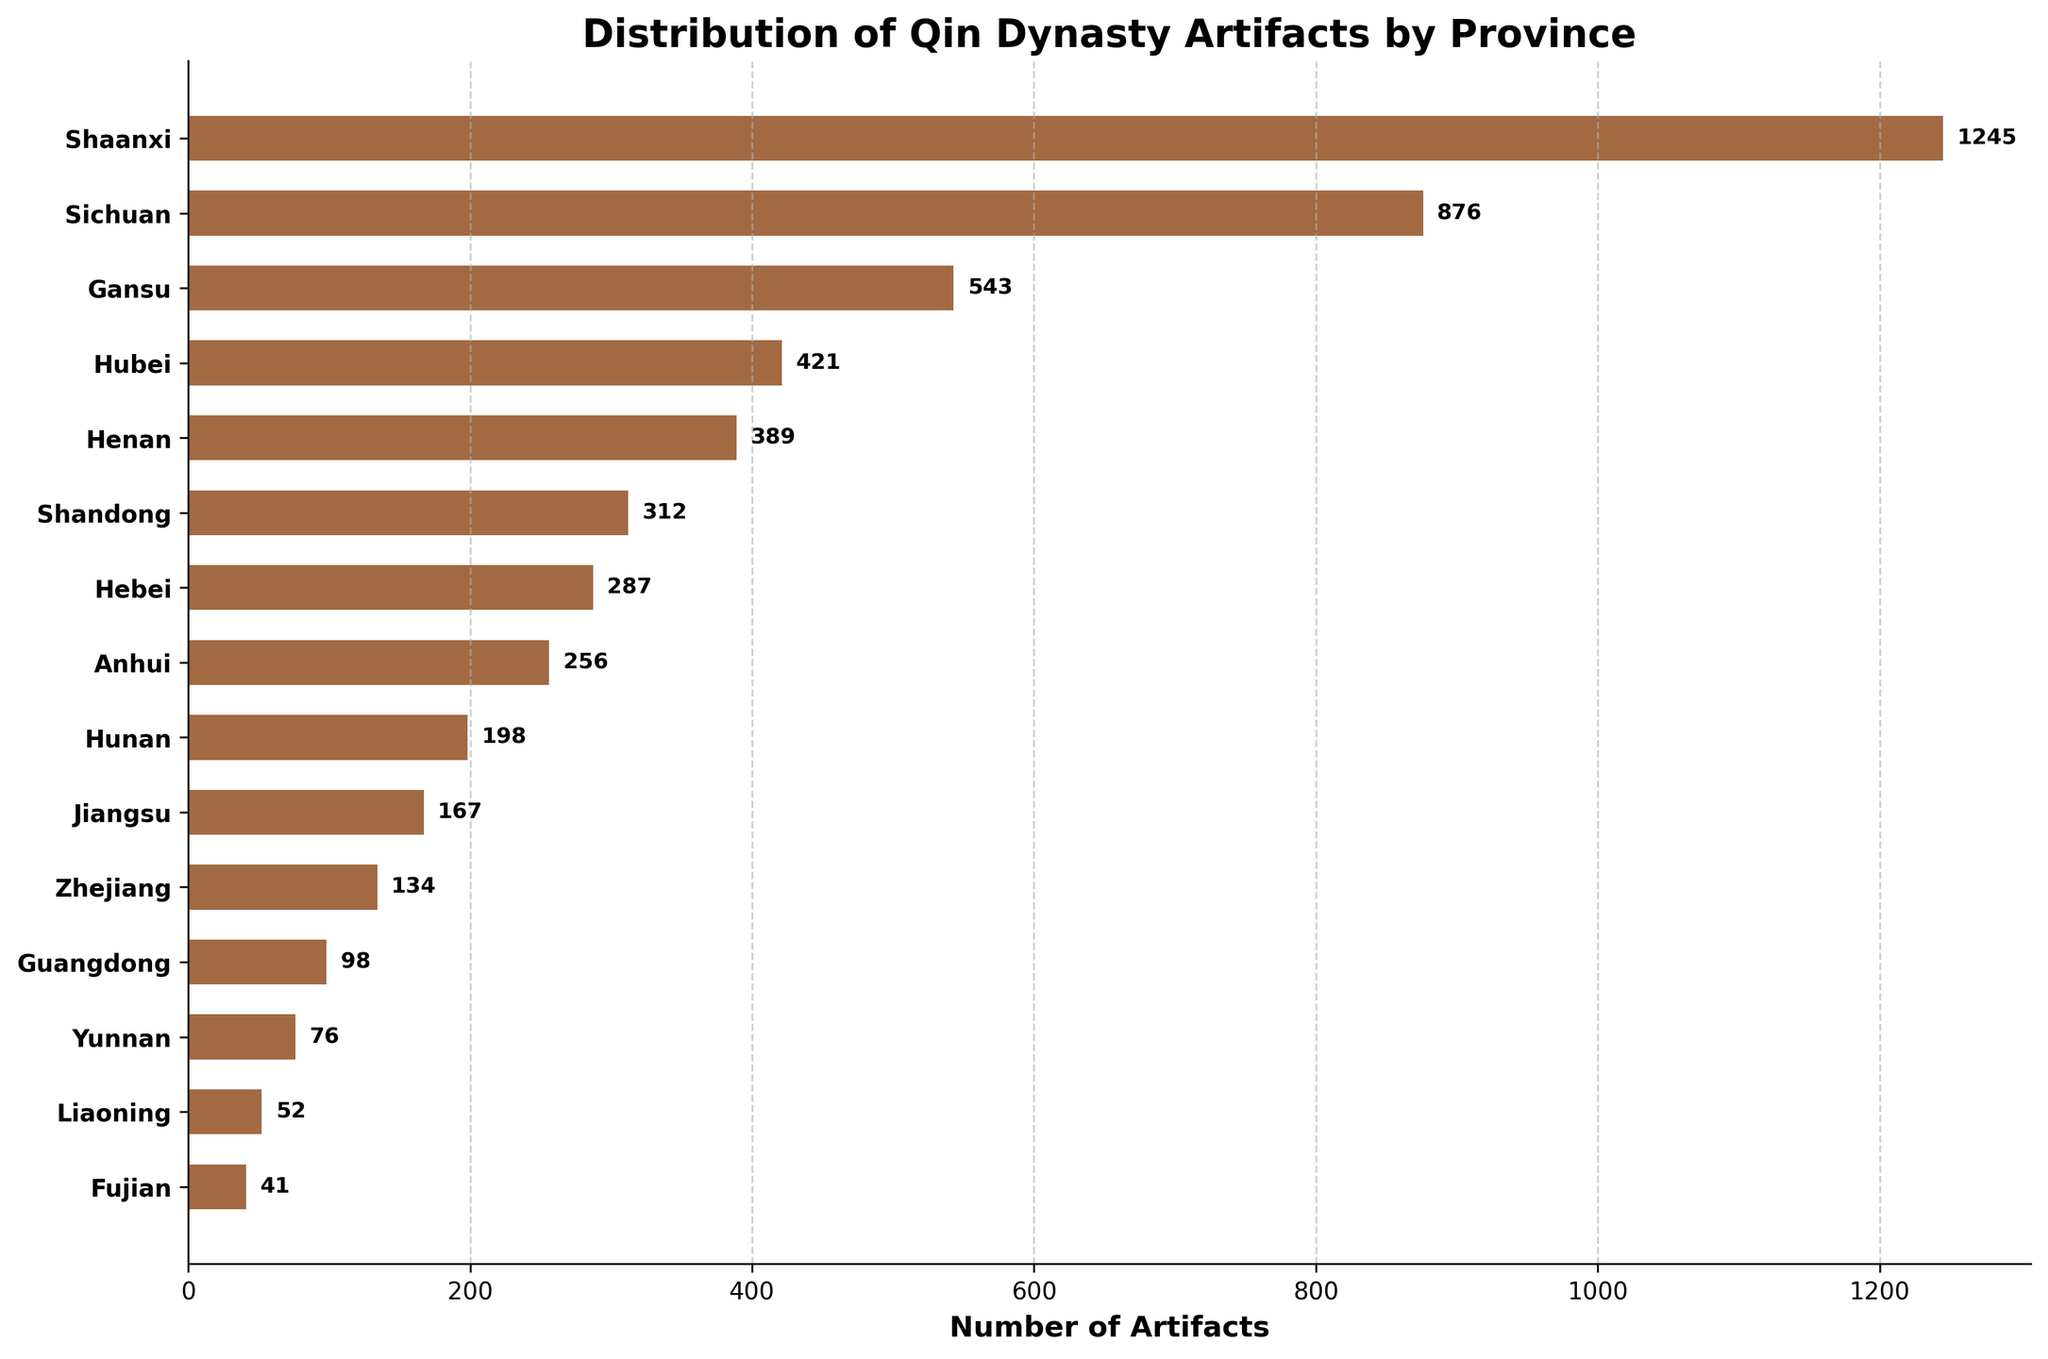Which province has the highest number of Qin Dynasty artifacts? The bar with the longest length corresponds to Shaanxi, indicating it has the highest number of artifacts.
Answer: Shaanxi What is the total number of artifacts found in Sichuan and Gansu combined? Summing the number of artifacts in Sichuan (876) and Gansu (543) results in: 876 + 543.
Answer: 1419 Which province has the least number of Qin Dynasty artifacts? The shortest bar corresponds to Fujian, indicating it has the least number of artifacts.
Answer: Fujian What is the approximate range of the number of artifacts found among the provinces? The highest number is 1245 (Shaanxi) and the lowest is 41 (Fujian). The range is 1245 - 41.
Answer: 1204 How many provinces found fewer than 100 Qin Dynasty artifacts? Identifying the bars representing fewer than 100 artifacts (Guangdong, Yunnan, Liaoning, Fujian) shows there are 4 such provinces.
Answer: 4 What is the average number of artifacts found across all the provinces? Adding the number of artifacts from all provinces and dividing by the number of provinces (15) gives the average.
Answer: 370.6 Which provinces have more than 500 Qin Dynasty artifacts? The bars longer than 500 correspond to Shaanxi, Sichuan, and Gansu.
Answer: Shaanxi, Sichuan, Gansu How many artifacts were found in the top three provinces combined? Summing the artifacts from Shaanxi (1245), Sichuan (876), and Gansu (543): 1245 + 876 + 543.
Answer: 2664 What percentage of the artifacts were found in Shaanxi relative to the total number of artifacts? Total artifacts is sum of all artifacts. Percentage is (1245/total) * 100.
Answer: 31.6% Which province has slightly more artifacts, Henan or Hubei? Comparing the bars for Henan (389) and Hubei (421) shows Hubei has slightly more.
Answer: Hubei 